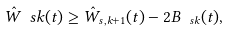Convert formula to latex. <formula><loc_0><loc_0><loc_500><loc_500>\hat { W } _ { \ } s k ( t ) \geq \hat { W } _ { s , k + 1 } ( t ) - 2 B _ { \ s k } ( t ) ,</formula> 